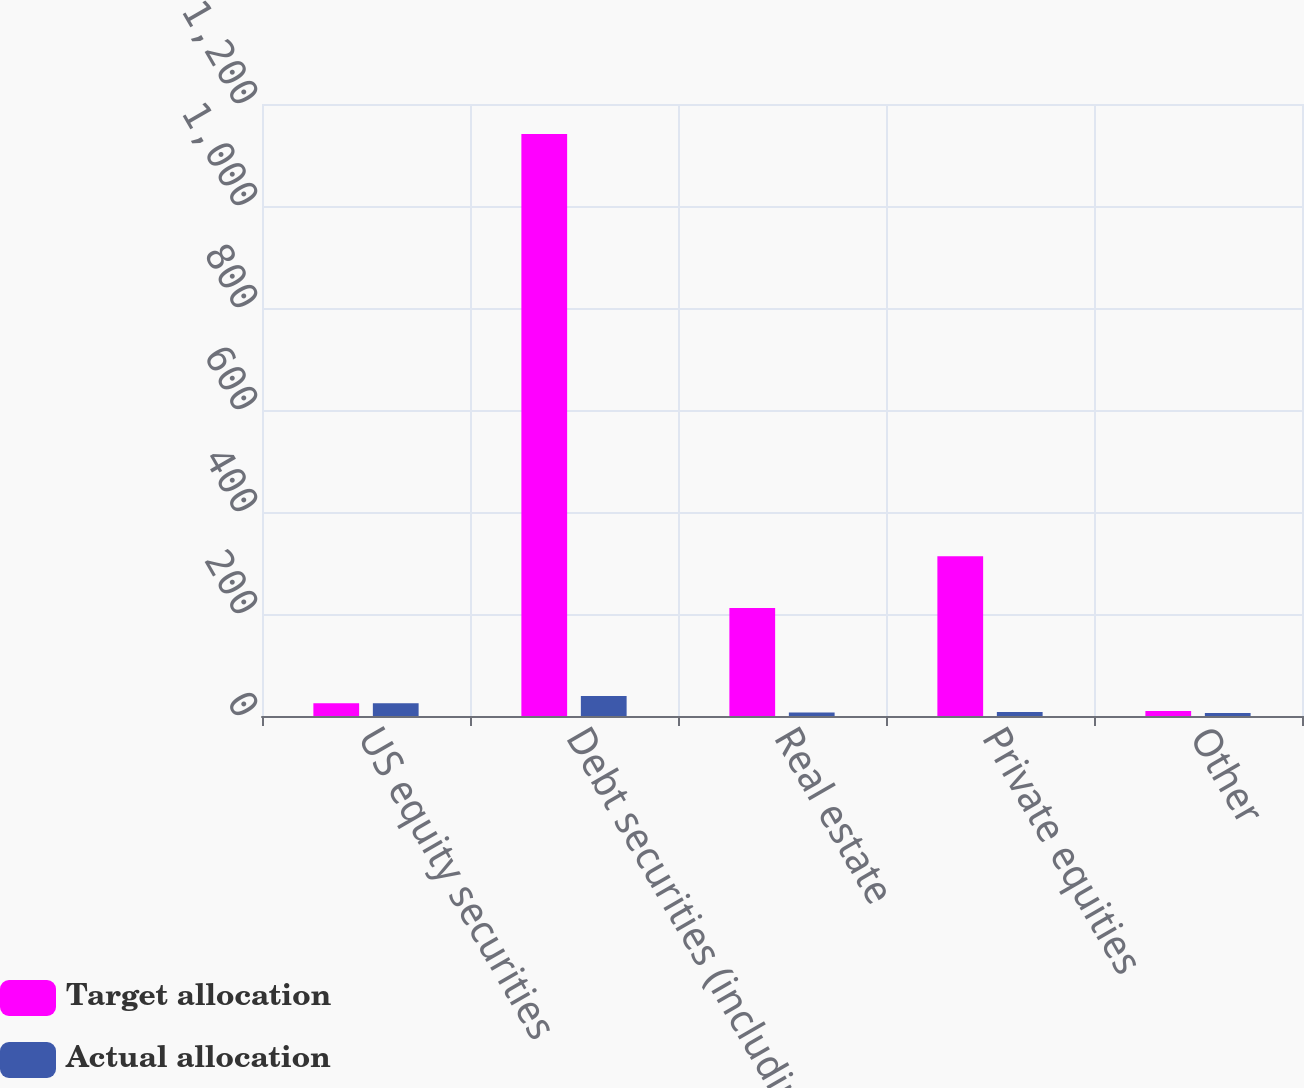Convert chart to OTSL. <chart><loc_0><loc_0><loc_500><loc_500><stacked_bar_chart><ecel><fcel>US equity securities<fcel>Debt securities (including<fcel>Real estate<fcel>Private equities<fcel>Other<nl><fcel>Target allocation<fcel>25<fcel>1141<fcel>212<fcel>313<fcel>10<nl><fcel>Actual allocation<fcel>25<fcel>39<fcel>7<fcel>8<fcel>6<nl></chart> 